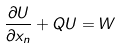<formula> <loc_0><loc_0><loc_500><loc_500>\frac { \partial U } { \partial x _ { n } } + Q U = W</formula> 